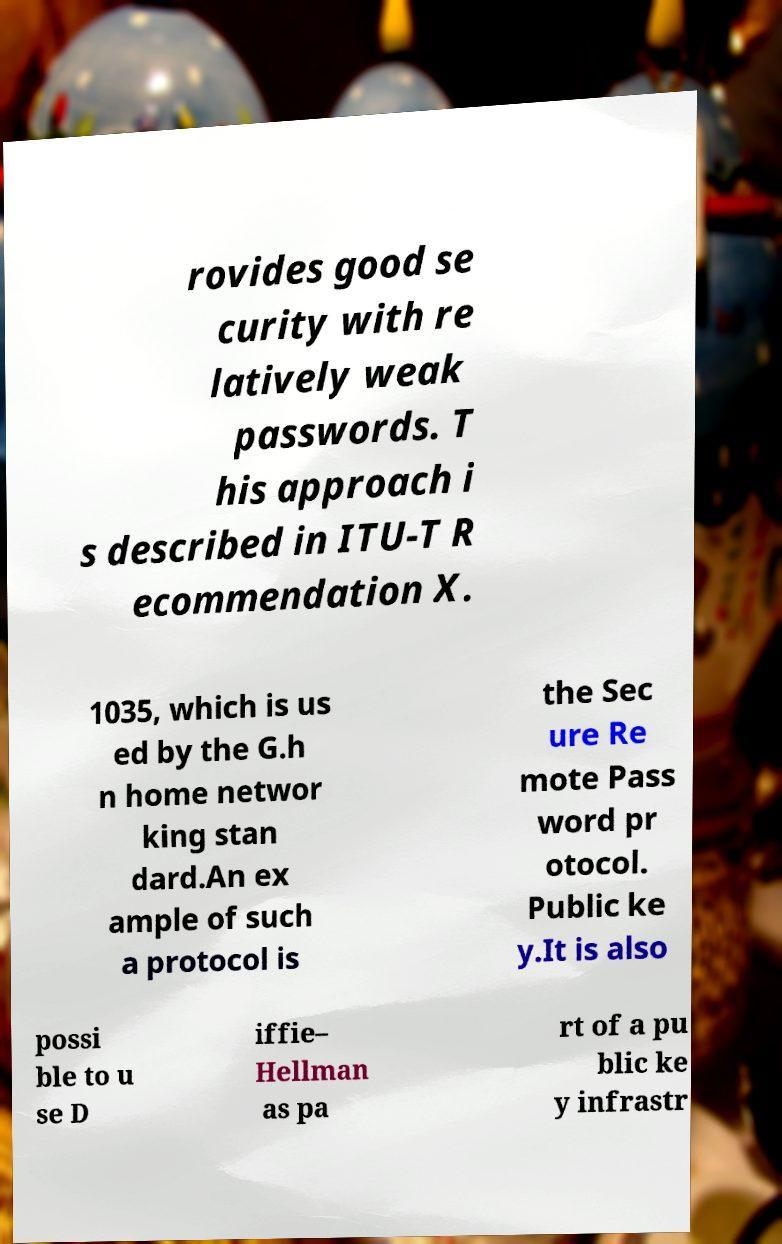Can you accurately transcribe the text from the provided image for me? rovides good se curity with re latively weak passwords. T his approach i s described in ITU-T R ecommendation X. 1035, which is us ed by the G.h n home networ king stan dard.An ex ample of such a protocol is the Sec ure Re mote Pass word pr otocol. Public ke y.It is also possi ble to u se D iffie– Hellman as pa rt of a pu blic ke y infrastr 